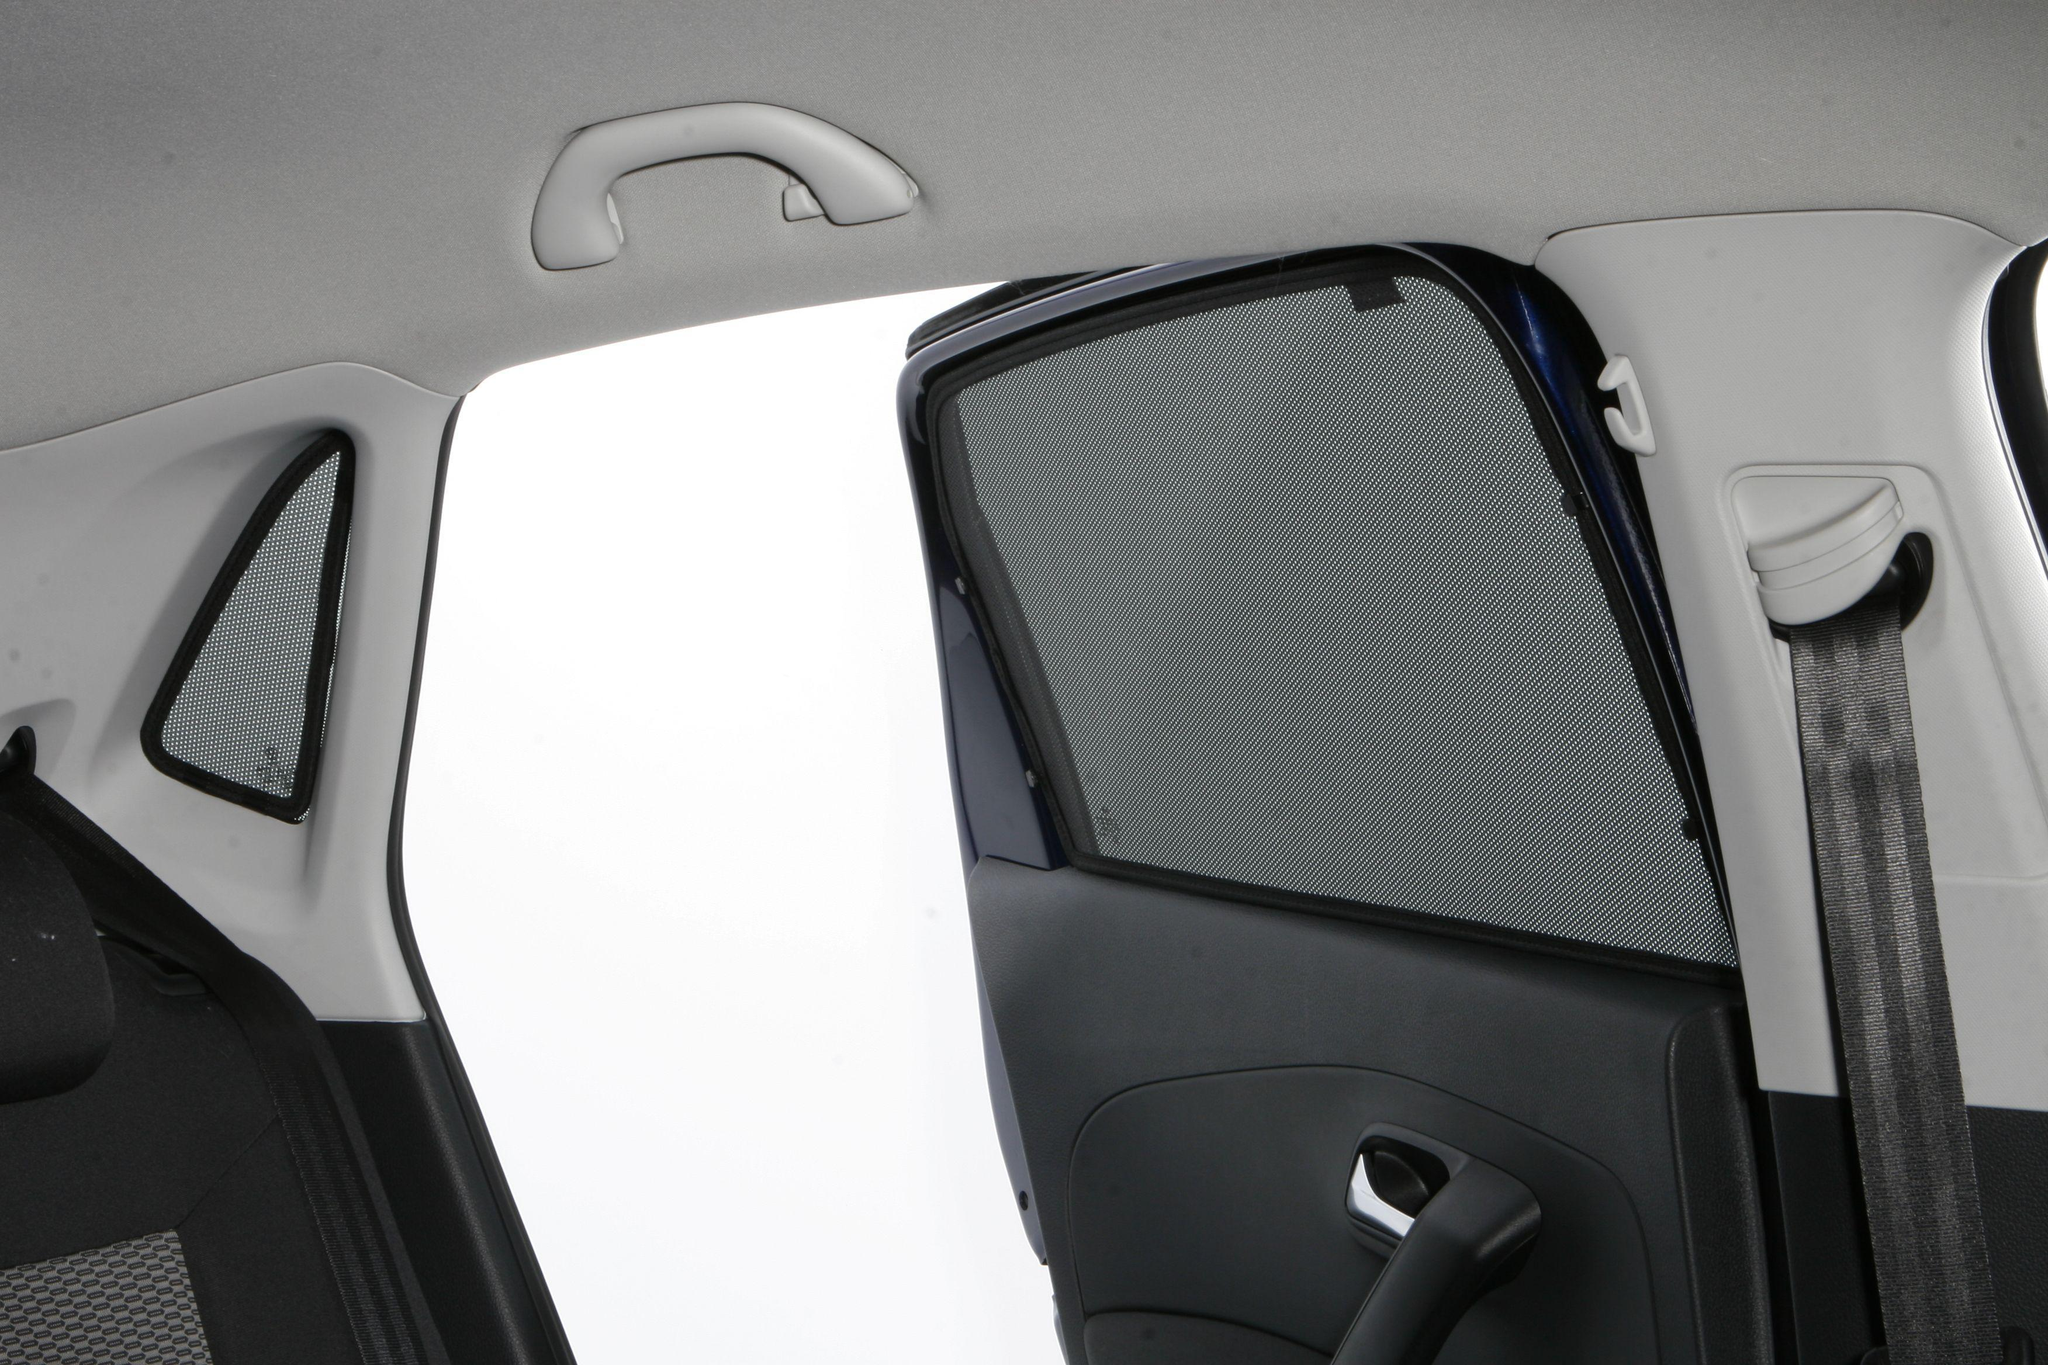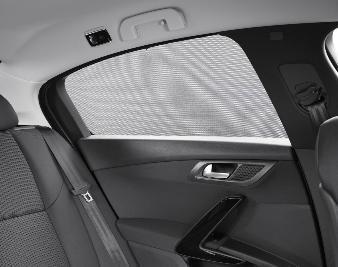The first image is the image on the left, the second image is the image on the right. Examine the images to the left and right. Is the description "The car door is ajar in one of the images." accurate? Answer yes or no. Yes. 